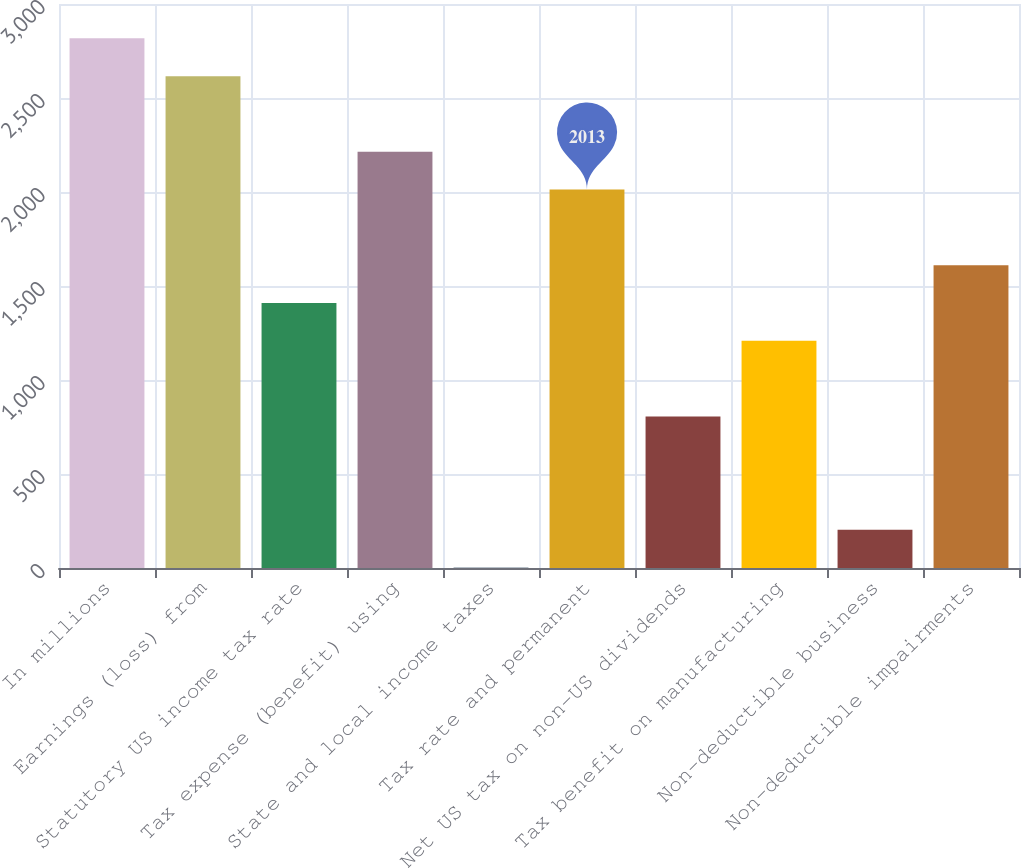Convert chart. <chart><loc_0><loc_0><loc_500><loc_500><bar_chart><fcel>In millions<fcel>Earnings (loss) from<fcel>Statutory US income tax rate<fcel>Tax expense (benefit) using<fcel>State and local income taxes<fcel>Tax rate and permanent<fcel>Net US tax on non-US dividends<fcel>Tax benefit on manufacturing<fcel>Non-deductible business<fcel>Non-deductible impairments<nl><fcel>2817.4<fcel>2616.3<fcel>1409.7<fcel>2214.1<fcel>2<fcel>2013<fcel>806.4<fcel>1208.6<fcel>203.1<fcel>1610.8<nl></chart> 